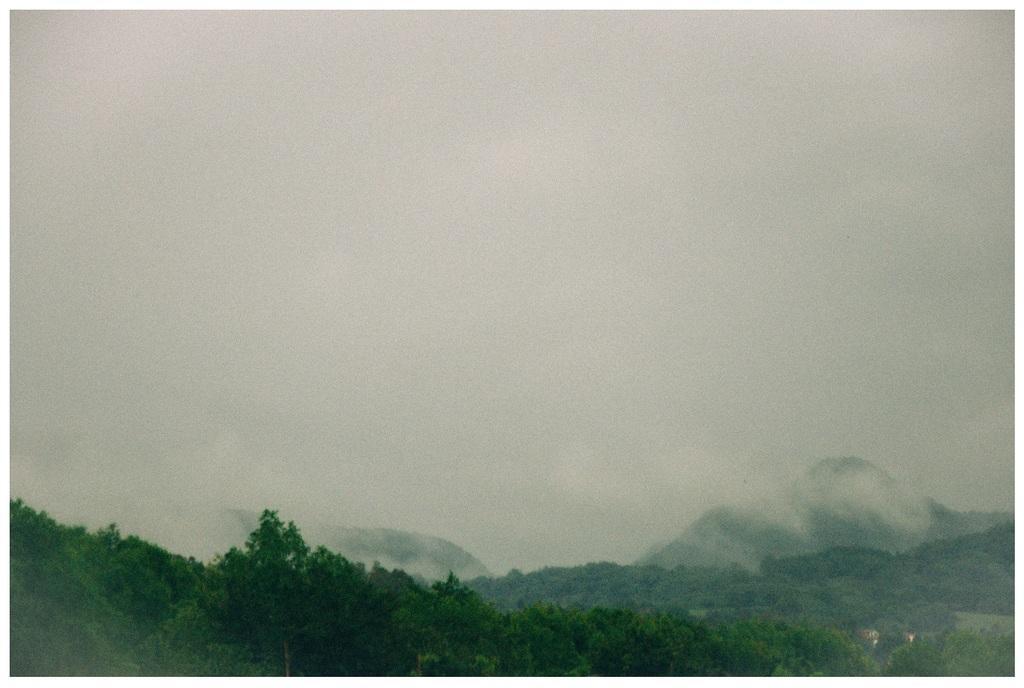Describe this image in one or two sentences. In this image we can see trees, mountains and sky. Far there are clouds. 